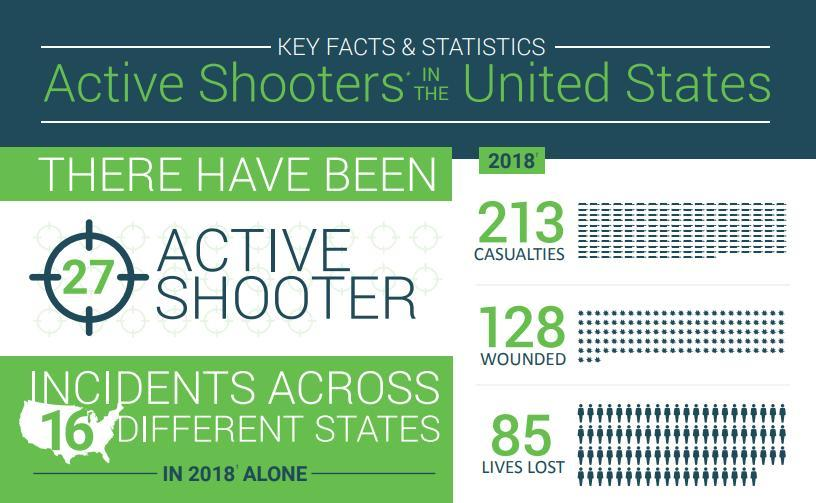How many casualties were observed across 16 different states in U.S. in 2018?
Answer the question with a short phrase. 213 How many were wounded across 16 different states in the U.S. in 2018? 128 What is the no of active shooters in the United States in 2018? 27 How many lost their lives across 16 different states in the U.S. in 2018? 85 